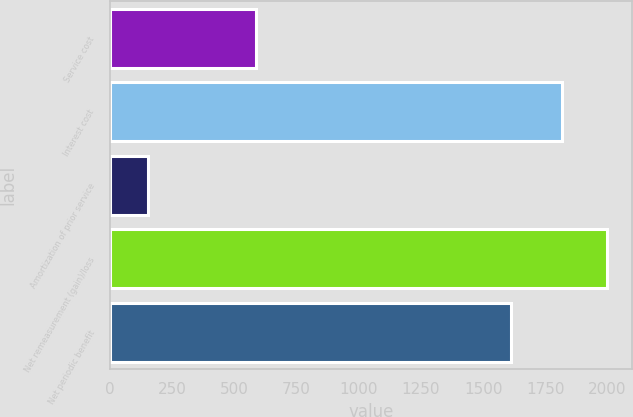<chart> <loc_0><loc_0><loc_500><loc_500><bar_chart><fcel>Service cost<fcel>Interest cost<fcel>Amortization of prior service<fcel>Net remeasurement (gain)/loss<fcel>Net periodic benefit<nl><fcel>586<fcel>1817<fcel>155<fcel>1997.9<fcel>1611<nl></chart> 